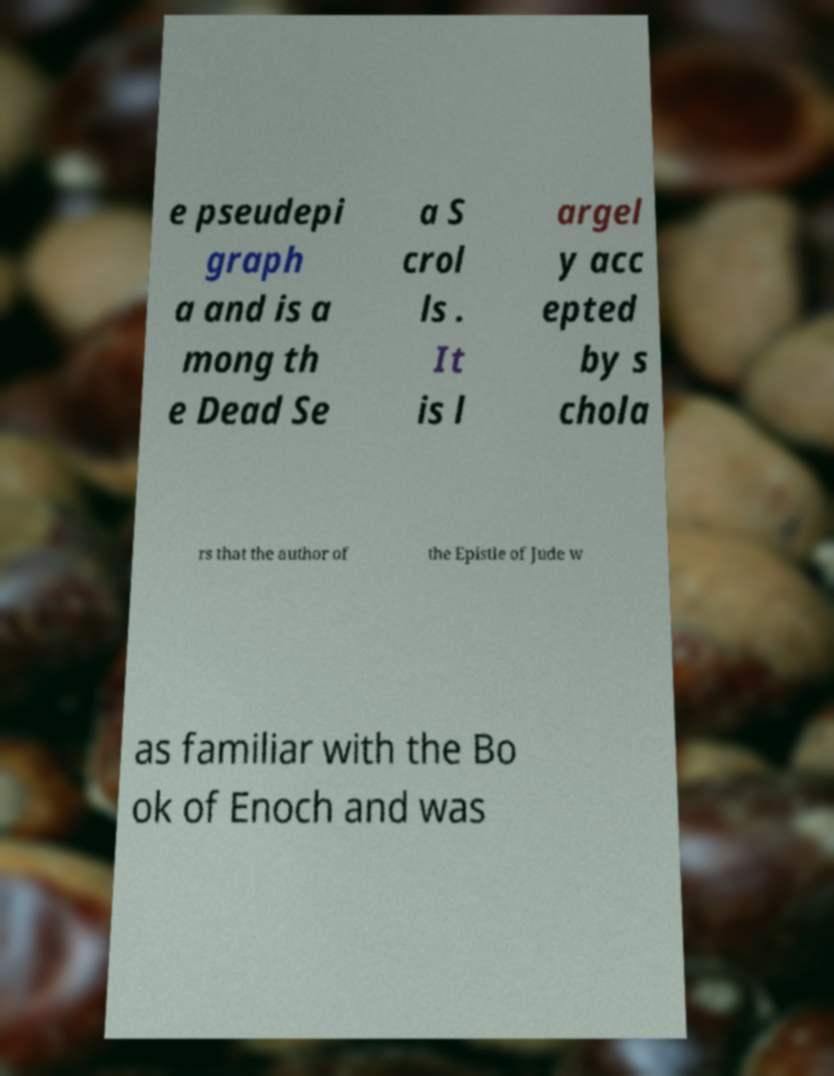Can you accurately transcribe the text from the provided image for me? e pseudepi graph a and is a mong th e Dead Se a S crol ls . It is l argel y acc epted by s chola rs that the author of the Epistle of Jude w as familiar with the Bo ok of Enoch and was 